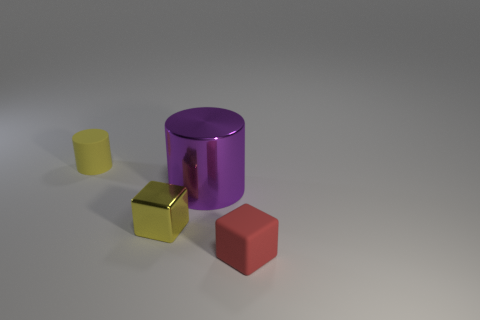Add 1 large shiny cubes. How many objects exist? 5 Subtract all red cubes. How many cubes are left? 1 Subtract 1 cubes. How many cubes are left? 1 Add 4 tiny yellow cylinders. How many tiny yellow cylinders are left? 5 Add 4 tiny cyan cylinders. How many tiny cyan cylinders exist? 4 Subtract 0 yellow spheres. How many objects are left? 4 Subtract all red blocks. Subtract all yellow cylinders. How many blocks are left? 1 Subtract all red shiny cubes. Subtract all small yellow rubber cylinders. How many objects are left? 3 